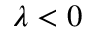Convert formula to latex. <formula><loc_0><loc_0><loc_500><loc_500>\lambda < 0</formula> 